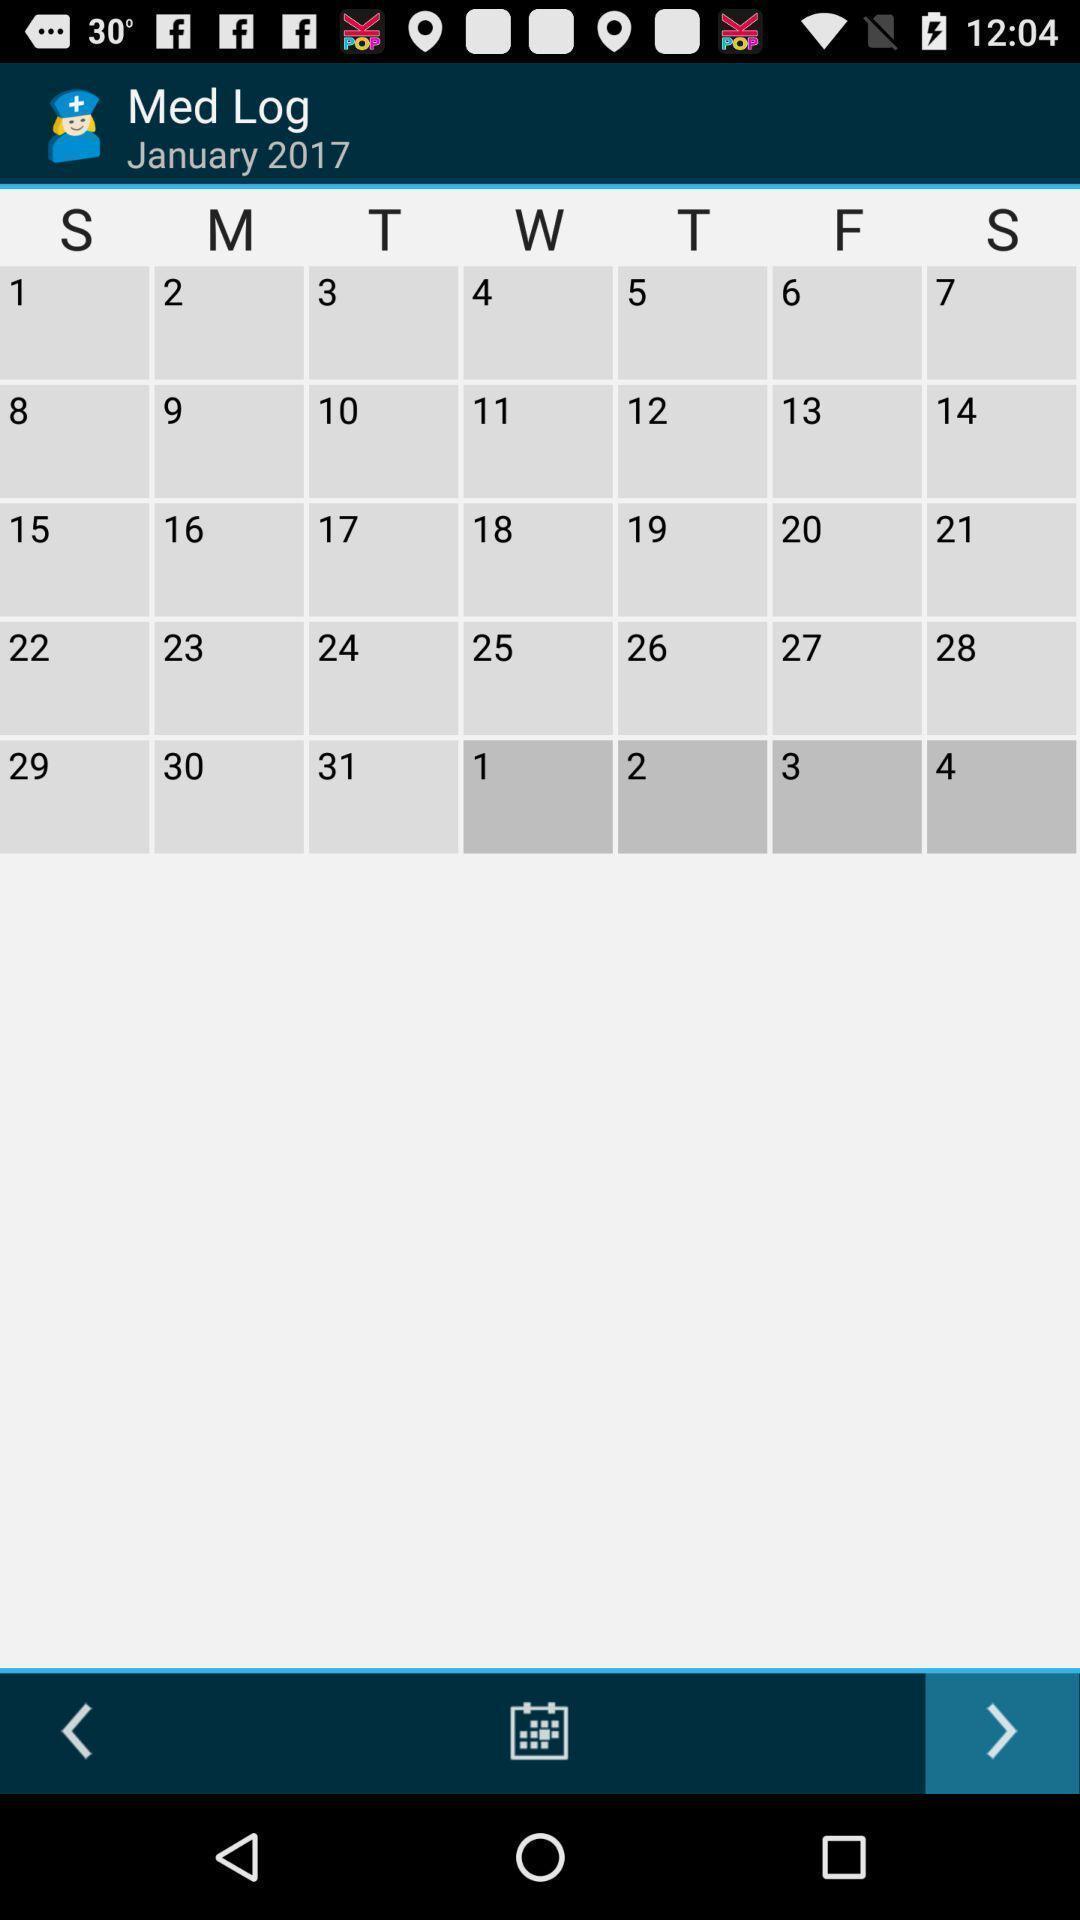Describe this image in words. Page displaying the calendar with next and previous options. 